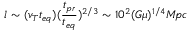Convert formula to latex. <formula><loc_0><loc_0><loc_500><loc_500>l \sim ( v _ { T } t _ { e q } ) ( \frac { t _ { p r } } { t _ { e q } } ) ^ { 2 / 3 } \sim 1 0 ^ { 2 } ( G \mu ) ^ { 1 / 4 } M \, p c</formula> 